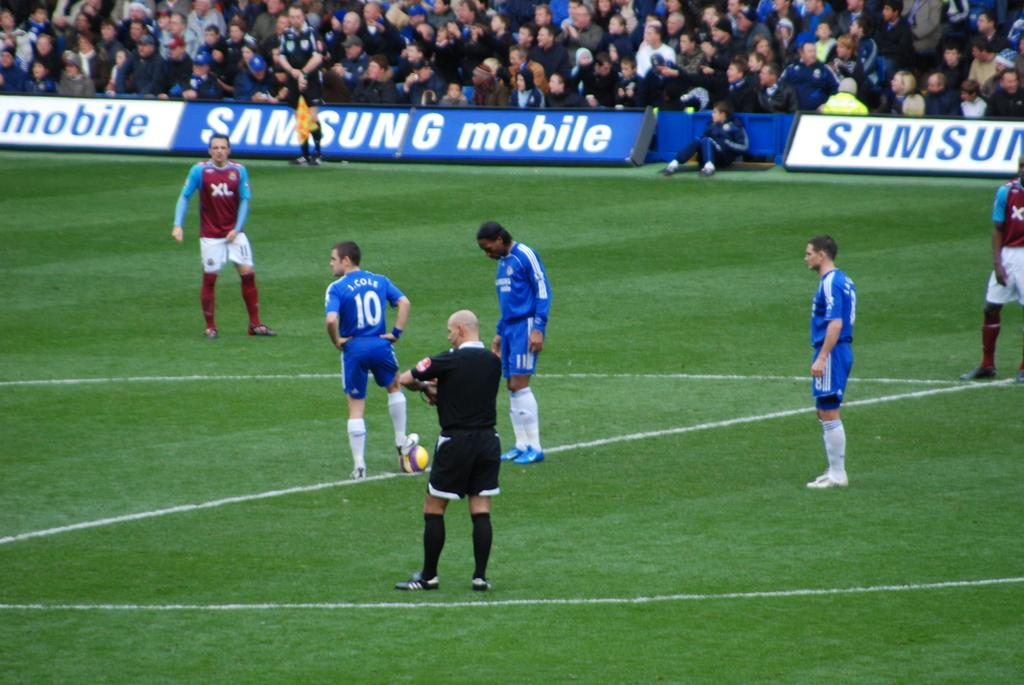<image>
Present a compact description of the photo's key features. A group of soccer players are standing on a field with Samsung ads on the sidelines. 